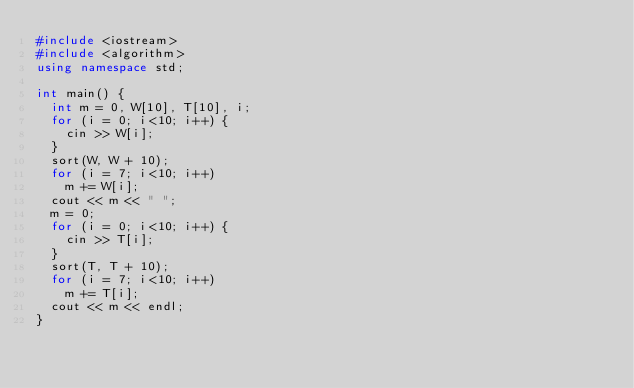Convert code to text. <code><loc_0><loc_0><loc_500><loc_500><_C++_>#include <iostream>
#include <algorithm>
using namespace std;

int main() {
	int m = 0, W[10], T[10], i;
	for (i = 0; i<10; i++) {
		cin >> W[i];
	}
	sort(W, W + 10);
	for (i = 7; i<10; i++)
		m += W[i];
	cout << m << " ";
	m = 0;
	for (i = 0; i<10; i++) {
		cin >> T[i];
	}
	sort(T, T + 10);
	for (i = 7; i<10; i++)
		m += T[i];
	cout << m << endl;
}</code> 